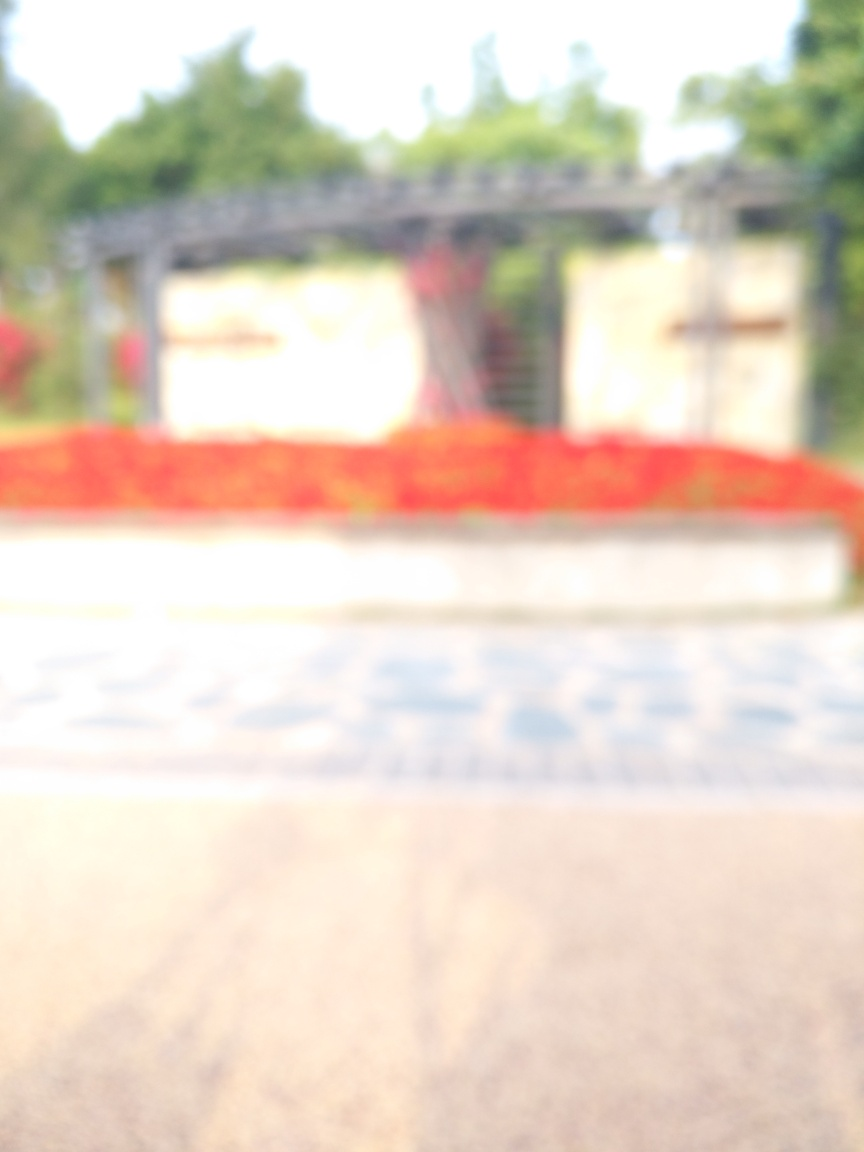Despite the blurriness, can you describe any details that are visible in the image? While distinct details are challenging to make out due to the low sharpness, we can observe broad strokes of color and light suggesting an outdoor setting with structures that might be architectural in nature, such as an entrance or gate, and vibrant red flora or decorative elements. Could the blurriness be purposeful, and if so, what might it convey? Artistic use of blur can evoke mystery, movement, or a dreamlike quality. If intentional, it might be aiming to trigger the viewer's imagination to fill in the details or to focus on the emotional rather than the literal aspects of the scene. 